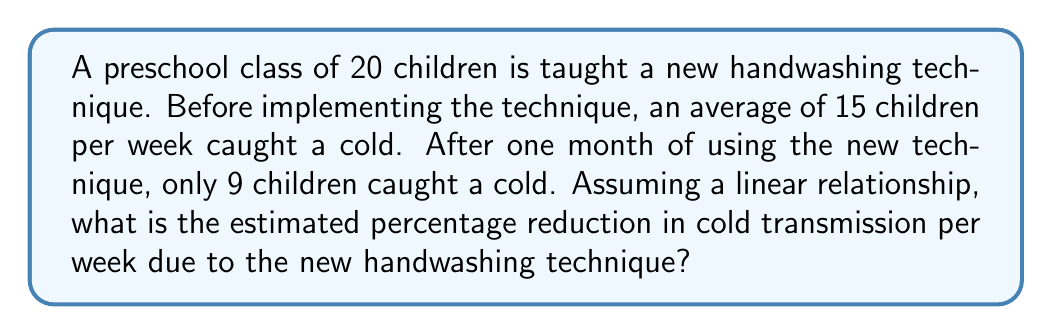Teach me how to tackle this problem. Let's approach this step-by-step:

1) First, we need to calculate the average number of children catching a cold per week after implementing the new technique:
   $\frac{9 \text{ children}}{4 \text{ weeks}} = 2.25 \text{ children per week}$

2) Now we can calculate the reduction in cold cases per week:
   $15 - 2.25 = 12.75 \text{ fewer cases per week}$

3) To find the percentage reduction, we use the formula:
   $$\text{Percentage Reduction} = \frac{\text{Reduction}}{\text{Original Value}} \times 100\%$$

4) Plugging in our values:
   $$\text{Percentage Reduction} = \frac{12.75}{15} \times 100\%$$

5) Simplifying:
   $$\text{Percentage Reduction} = 0.85 \times 100\% = 85\%$$

Therefore, the estimated percentage reduction in cold transmission per week due to the new handwashing technique is 85%.
Answer: 85% 